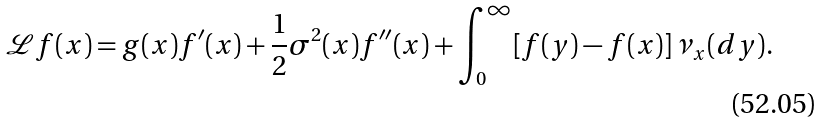<formula> <loc_0><loc_0><loc_500><loc_500>\mathcal { L } f ( x ) = g ( x ) f ^ { \prime } ( x ) + \frac { 1 } { 2 } \sigma ^ { 2 } ( x ) f ^ { \prime \prime } ( x ) + \int _ { 0 } ^ { \infty } [ f ( y ) - f ( x ) ] \, \nu _ { x } ( d y ) .</formula> 